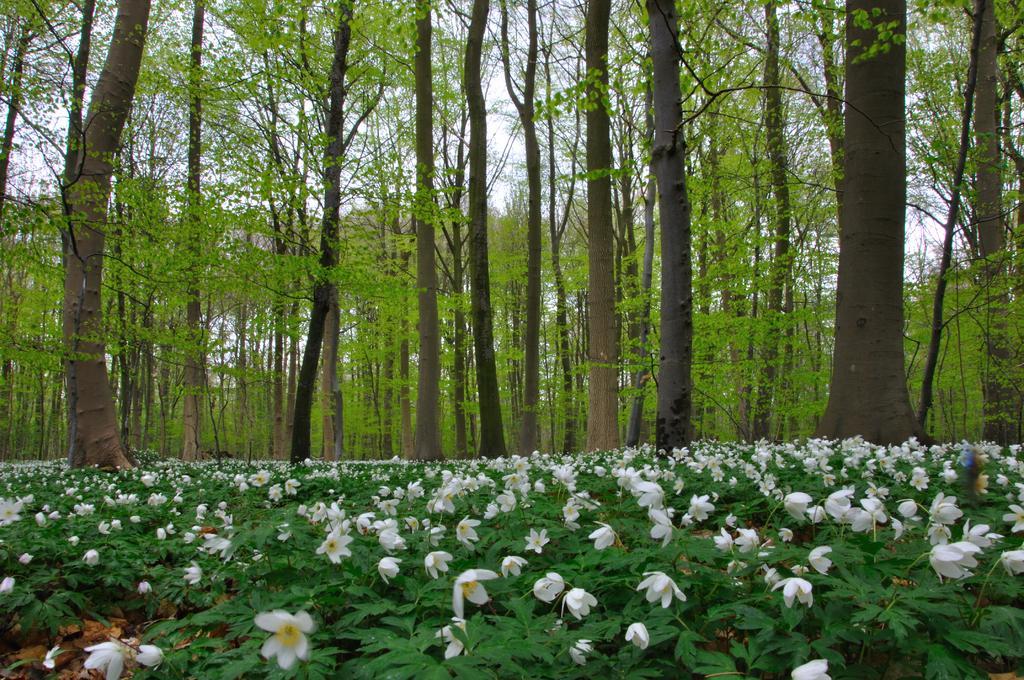Please provide a concise description of this image. In the image in the center we can see plants and few flowers,which are in white and yellow color. In the background we can see the sky,clouds and trees. 